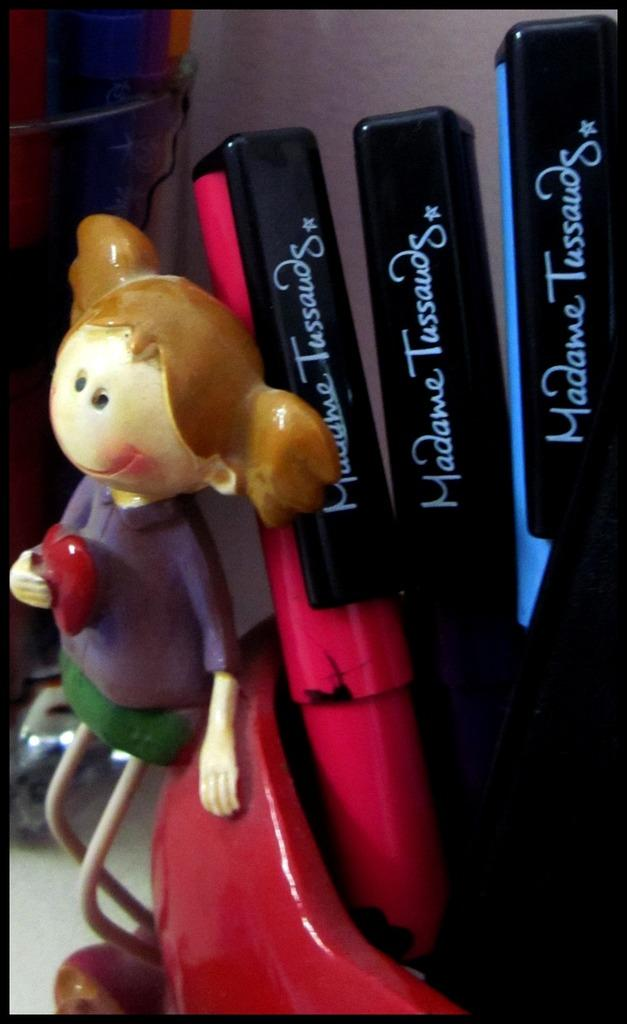Provide a one-sentence caption for the provided image. Three pens from Madame Tussauds are in a red container with a girl figurine next to it. 